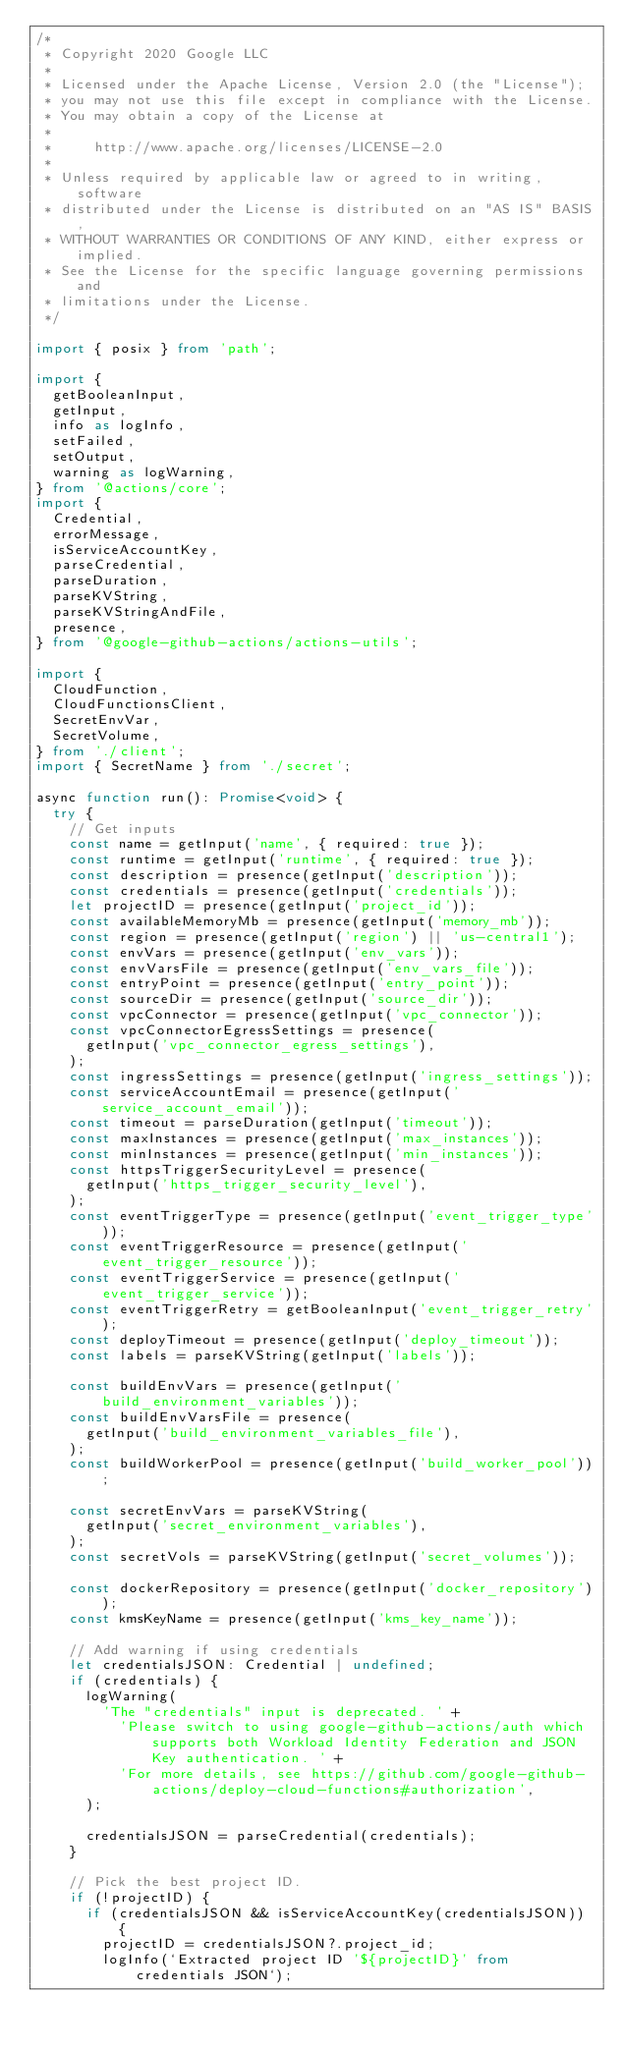<code> <loc_0><loc_0><loc_500><loc_500><_TypeScript_>/*
 * Copyright 2020 Google LLC
 *
 * Licensed under the Apache License, Version 2.0 (the "License");
 * you may not use this file except in compliance with the License.
 * You may obtain a copy of the License at
 *
 *     http://www.apache.org/licenses/LICENSE-2.0
 *
 * Unless required by applicable law or agreed to in writing, software
 * distributed under the License is distributed on an "AS IS" BASIS,
 * WITHOUT WARRANTIES OR CONDITIONS OF ANY KIND, either express or implied.
 * See the License for the specific language governing permissions and
 * limitations under the License.
 */

import { posix } from 'path';

import {
  getBooleanInput,
  getInput,
  info as logInfo,
  setFailed,
  setOutput,
  warning as logWarning,
} from '@actions/core';
import {
  Credential,
  errorMessage,
  isServiceAccountKey,
  parseCredential,
  parseDuration,
  parseKVString,
  parseKVStringAndFile,
  presence,
} from '@google-github-actions/actions-utils';

import {
  CloudFunction,
  CloudFunctionsClient,
  SecretEnvVar,
  SecretVolume,
} from './client';
import { SecretName } from './secret';

async function run(): Promise<void> {
  try {
    // Get inputs
    const name = getInput('name', { required: true });
    const runtime = getInput('runtime', { required: true });
    const description = presence(getInput('description'));
    const credentials = presence(getInput('credentials'));
    let projectID = presence(getInput('project_id'));
    const availableMemoryMb = presence(getInput('memory_mb'));
    const region = presence(getInput('region') || 'us-central1');
    const envVars = presence(getInput('env_vars'));
    const envVarsFile = presence(getInput('env_vars_file'));
    const entryPoint = presence(getInput('entry_point'));
    const sourceDir = presence(getInput('source_dir'));
    const vpcConnector = presence(getInput('vpc_connector'));
    const vpcConnectorEgressSettings = presence(
      getInput('vpc_connector_egress_settings'),
    );
    const ingressSettings = presence(getInput('ingress_settings'));
    const serviceAccountEmail = presence(getInput('service_account_email'));
    const timeout = parseDuration(getInput('timeout'));
    const maxInstances = presence(getInput('max_instances'));
    const minInstances = presence(getInput('min_instances'));
    const httpsTriggerSecurityLevel = presence(
      getInput('https_trigger_security_level'),
    );
    const eventTriggerType = presence(getInput('event_trigger_type'));
    const eventTriggerResource = presence(getInput('event_trigger_resource'));
    const eventTriggerService = presence(getInput('event_trigger_service'));
    const eventTriggerRetry = getBooleanInput('event_trigger_retry');
    const deployTimeout = presence(getInput('deploy_timeout'));
    const labels = parseKVString(getInput('labels'));

    const buildEnvVars = presence(getInput('build_environment_variables'));
    const buildEnvVarsFile = presence(
      getInput('build_environment_variables_file'),
    );
    const buildWorkerPool = presence(getInput('build_worker_pool'));

    const secretEnvVars = parseKVString(
      getInput('secret_environment_variables'),
    );
    const secretVols = parseKVString(getInput('secret_volumes'));

    const dockerRepository = presence(getInput('docker_repository'));
    const kmsKeyName = presence(getInput('kms_key_name'));

    // Add warning if using credentials
    let credentialsJSON: Credential | undefined;
    if (credentials) {
      logWarning(
        'The "credentials" input is deprecated. ' +
          'Please switch to using google-github-actions/auth which supports both Workload Identity Federation and JSON Key authentication. ' +
          'For more details, see https://github.com/google-github-actions/deploy-cloud-functions#authorization',
      );

      credentialsJSON = parseCredential(credentials);
    }

    // Pick the best project ID.
    if (!projectID) {
      if (credentialsJSON && isServiceAccountKey(credentialsJSON)) {
        projectID = credentialsJSON?.project_id;
        logInfo(`Extracted project ID '${projectID}' from credentials JSON`);</code> 